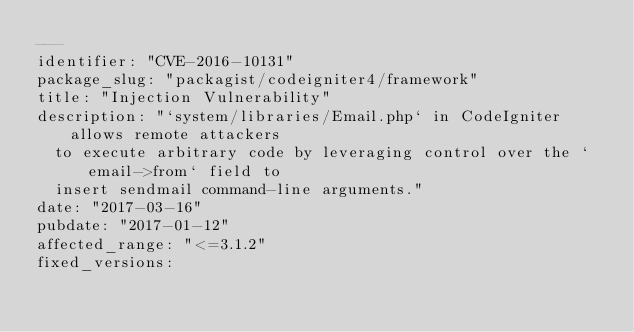Convert code to text. <code><loc_0><loc_0><loc_500><loc_500><_YAML_>---
identifier: "CVE-2016-10131"
package_slug: "packagist/codeigniter4/framework"
title: "Injection Vulnerability"
description: "`system/libraries/Email.php` in CodeIgniter allows remote attackers
  to execute arbitrary code by leveraging control over the `email->from` field to
  insert sendmail command-line arguments."
date: "2017-03-16"
pubdate: "2017-01-12"
affected_range: "<=3.1.2"
fixed_versions:</code> 